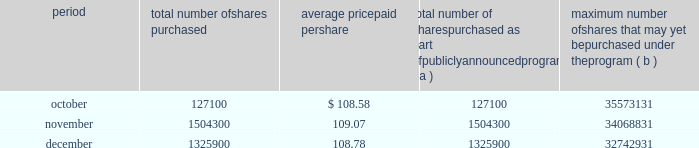Issuer purchases of equity securities the table provides information about our repurchases of common stock during the three-month period ended december 31 , 2007 .
Period total number of shares purchased average price paid per total number of shares purchased as part of publicly announced program ( a ) maximum number of shares that may yet be purchased under the program ( b ) .
( a ) we repurchased a total of 2957300 shares of our common stock during the quarter ended december 31 , 2007 under a share repurchase program that we announced in october 2002 .
( b ) our board of directors has approved a share repurchase program for the repurchase of up to 128 million shares of our common stock from time-to-time , including 20 million shares approved for repurchase by our board of directors in september 2007 .
Under the program , management has discretion to determine the number and price of the shares to be repurchased , and the timing of any repurchases , in compliance with applicable law and regulation .
As of december 31 , 2007 , we had repurchased a total of 95.3 million shares under the program .
In 2007 , we did not make any unregistered sales of equity securities. .
For the quarter ended december 31 , 2007 what was the percent of the shared bought in october? 
Computations: (127100 / 2957300)
Answer: 0.04298. 